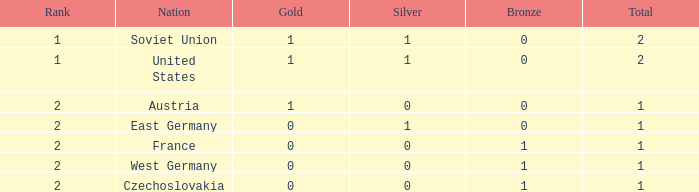What is the rank of the team with 0 gold and less than 0 silvers? None. 